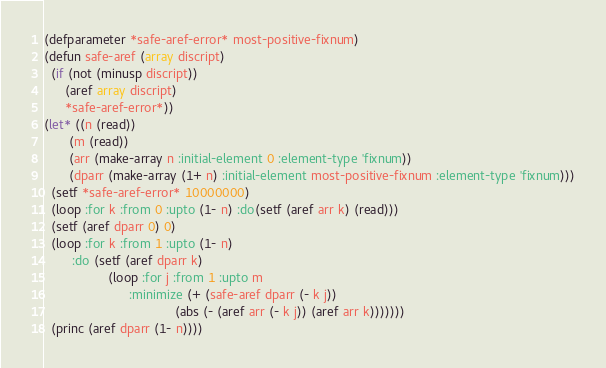<code> <loc_0><loc_0><loc_500><loc_500><_Lisp_>(defparameter *safe-aref-error* most-positive-fixnum)
(defun safe-aref (array discript)
  (if (not (minusp discript))
      (aref array discript)
      *safe-aref-error*))
(let* ((n (read))
       (m (read))
       (arr (make-array n :initial-element 0 :element-type 'fixnum))
       (dparr (make-array (1+ n) :initial-element most-positive-fixnum :element-type 'fixnum)))
  (setf *safe-aref-error* 10000000)
  (loop :for k :from 0 :upto (1- n) :do(setf (aref arr k) (read)))
  (setf (aref dparr 0) 0)
  (loop :for k :from 1 :upto (1- n)
        :do (setf (aref dparr k)
                  (loop :for j :from 1 :upto m
                        :minimize (+ (safe-aref dparr (- k j))
                                     (abs (- (aref arr (- k j)) (aref arr k)))))))
  (princ (aref dparr (1- n))))
</code> 